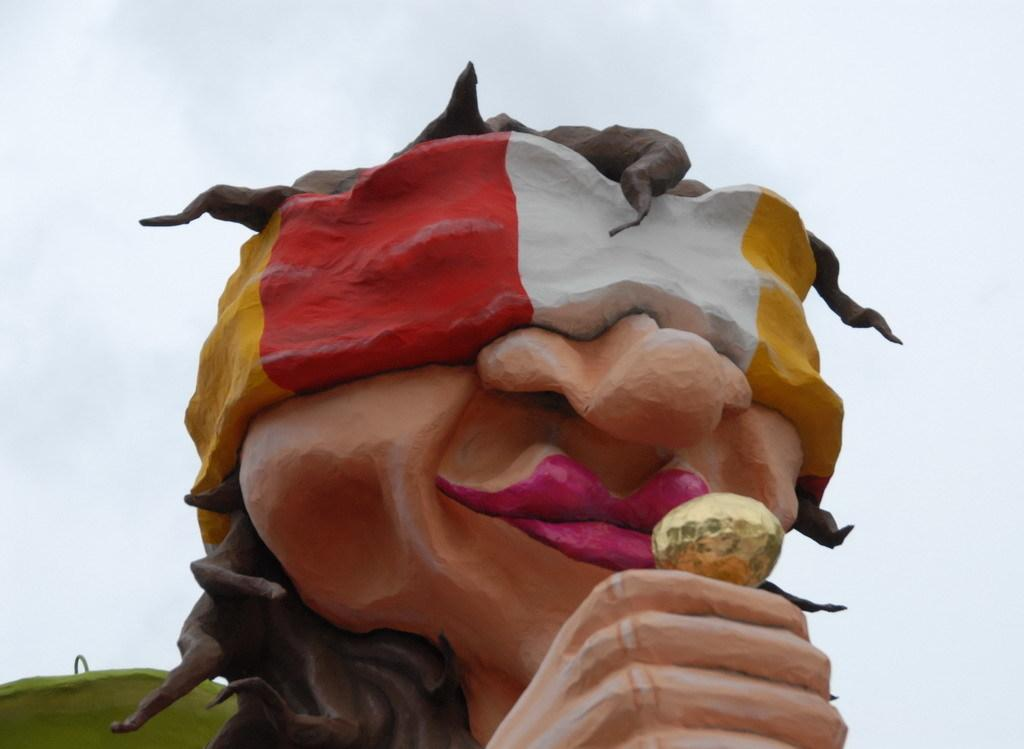What is the main subject in the image? There is a statue in the image. What can be seen in the background of the image? The sky is visible in the background of the image. How many trees are present in the image? There is no tree present in the image; it only features a statue and the sky in the background. 